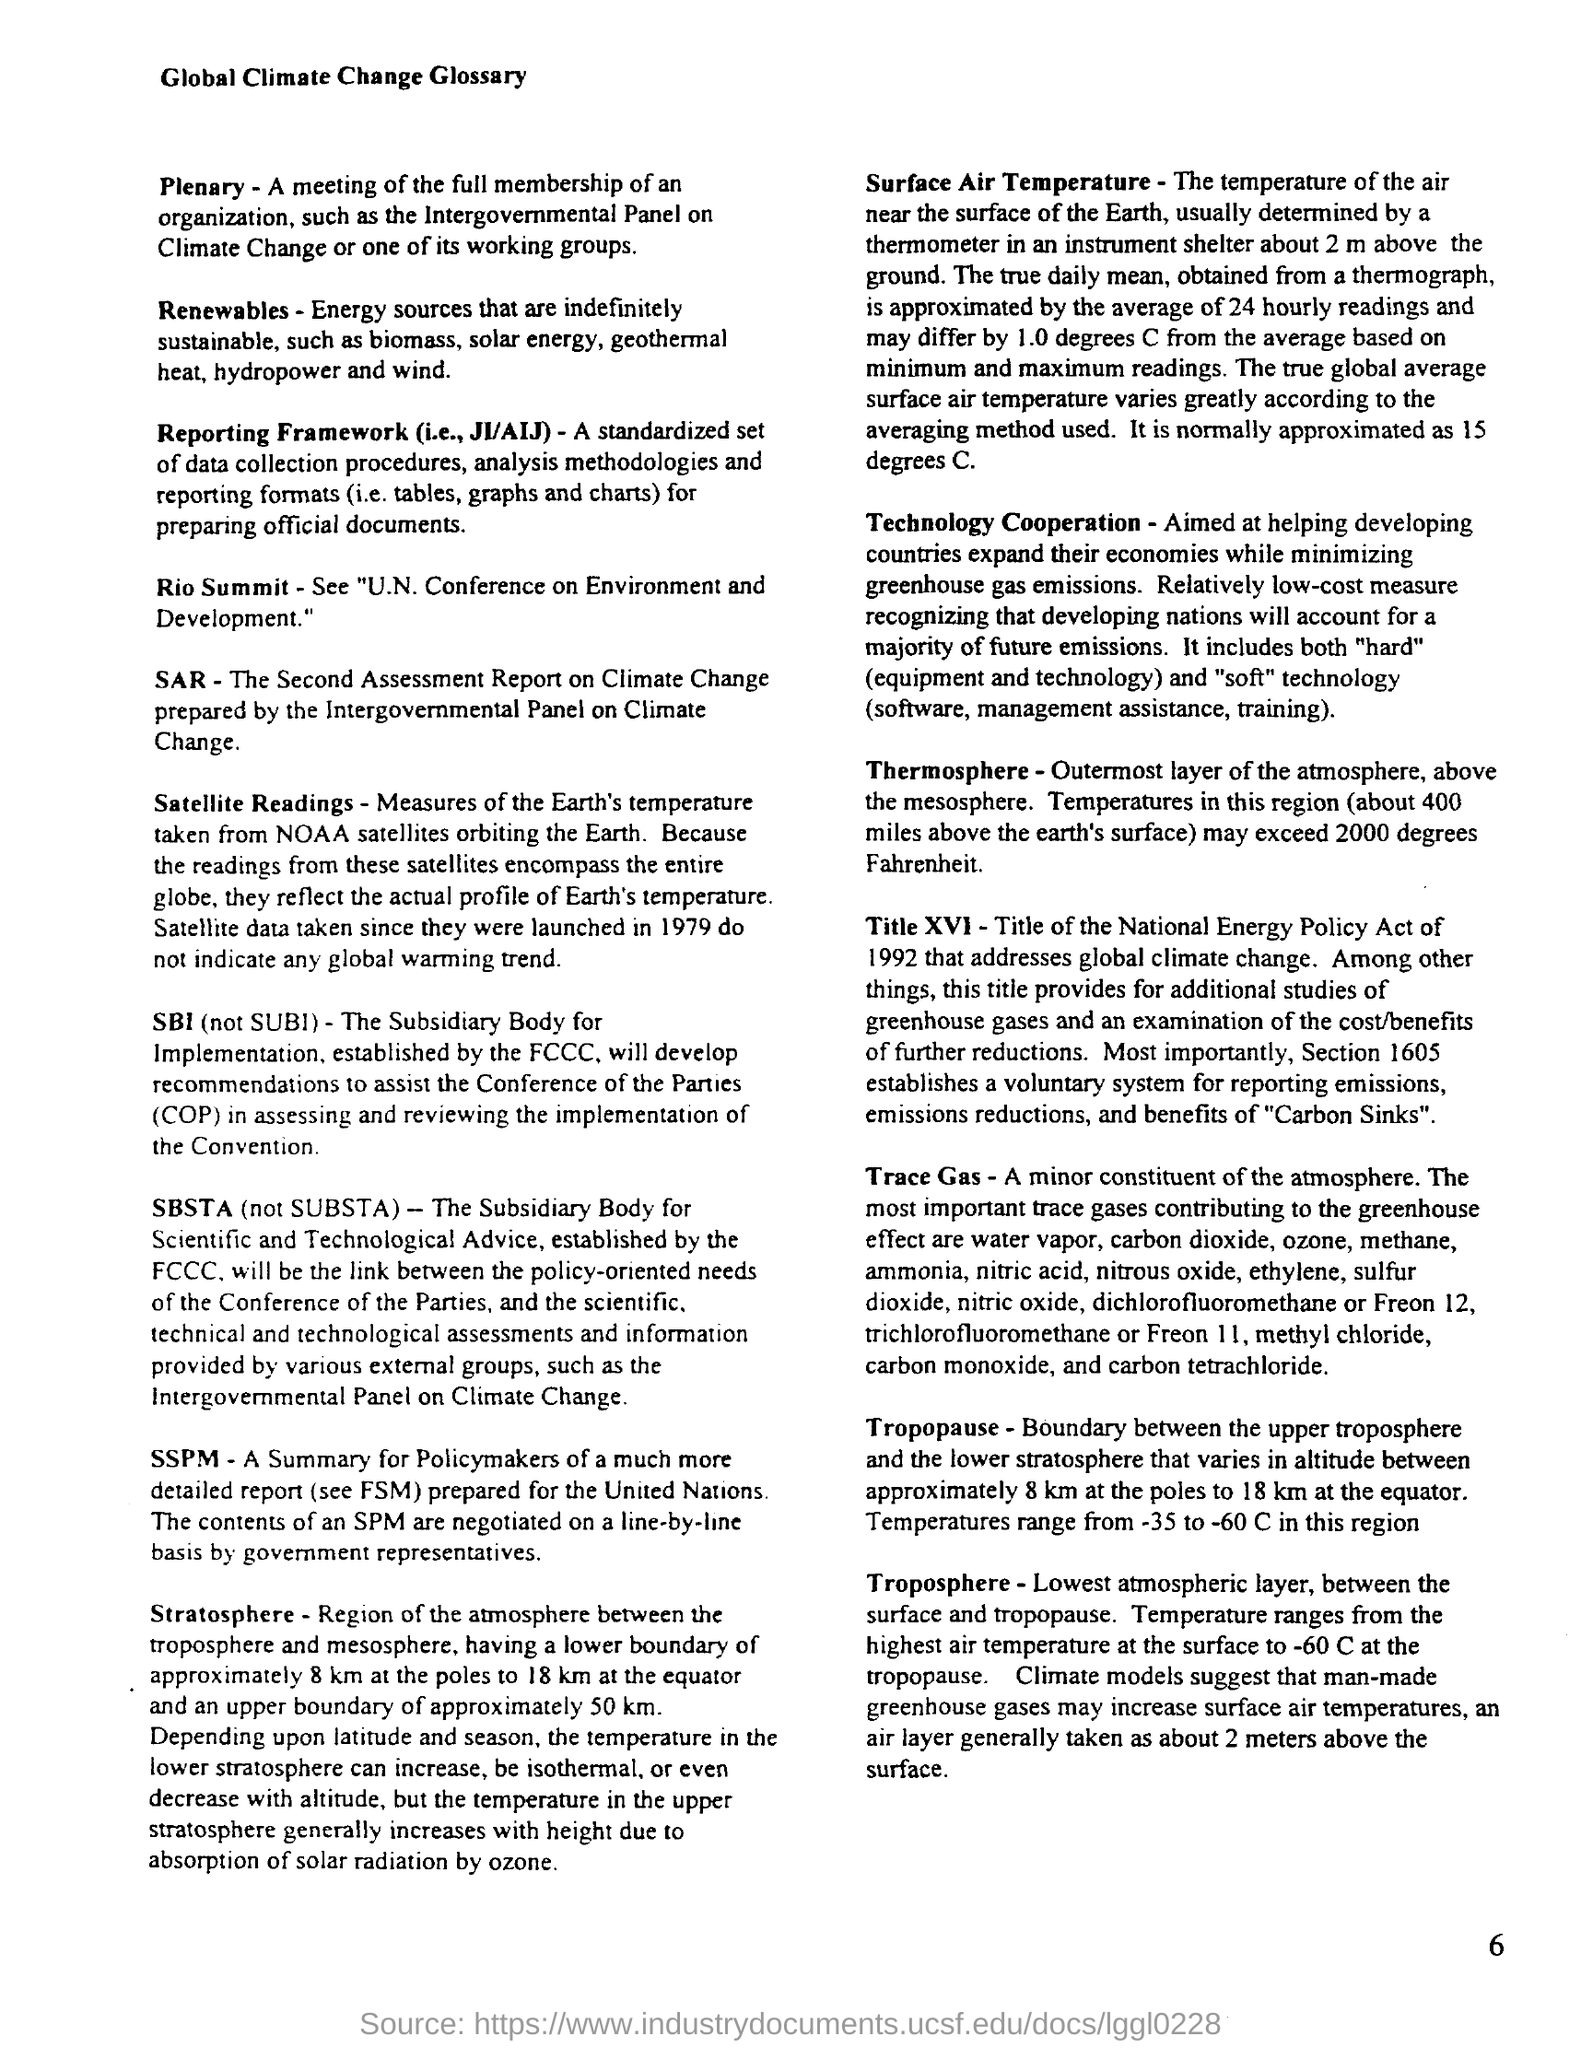Specify some key components in this picture. Title XVI addresses global climate change. The true global average surface air temperature is approximated to be 15 degrees Celsius. Renewables refer to energy sources that are indefinitely sustainable and cannot be exhausted, such as wind, solar, hydro, and geothermal energy. The document is about Global Climate Change and its related terminology. 